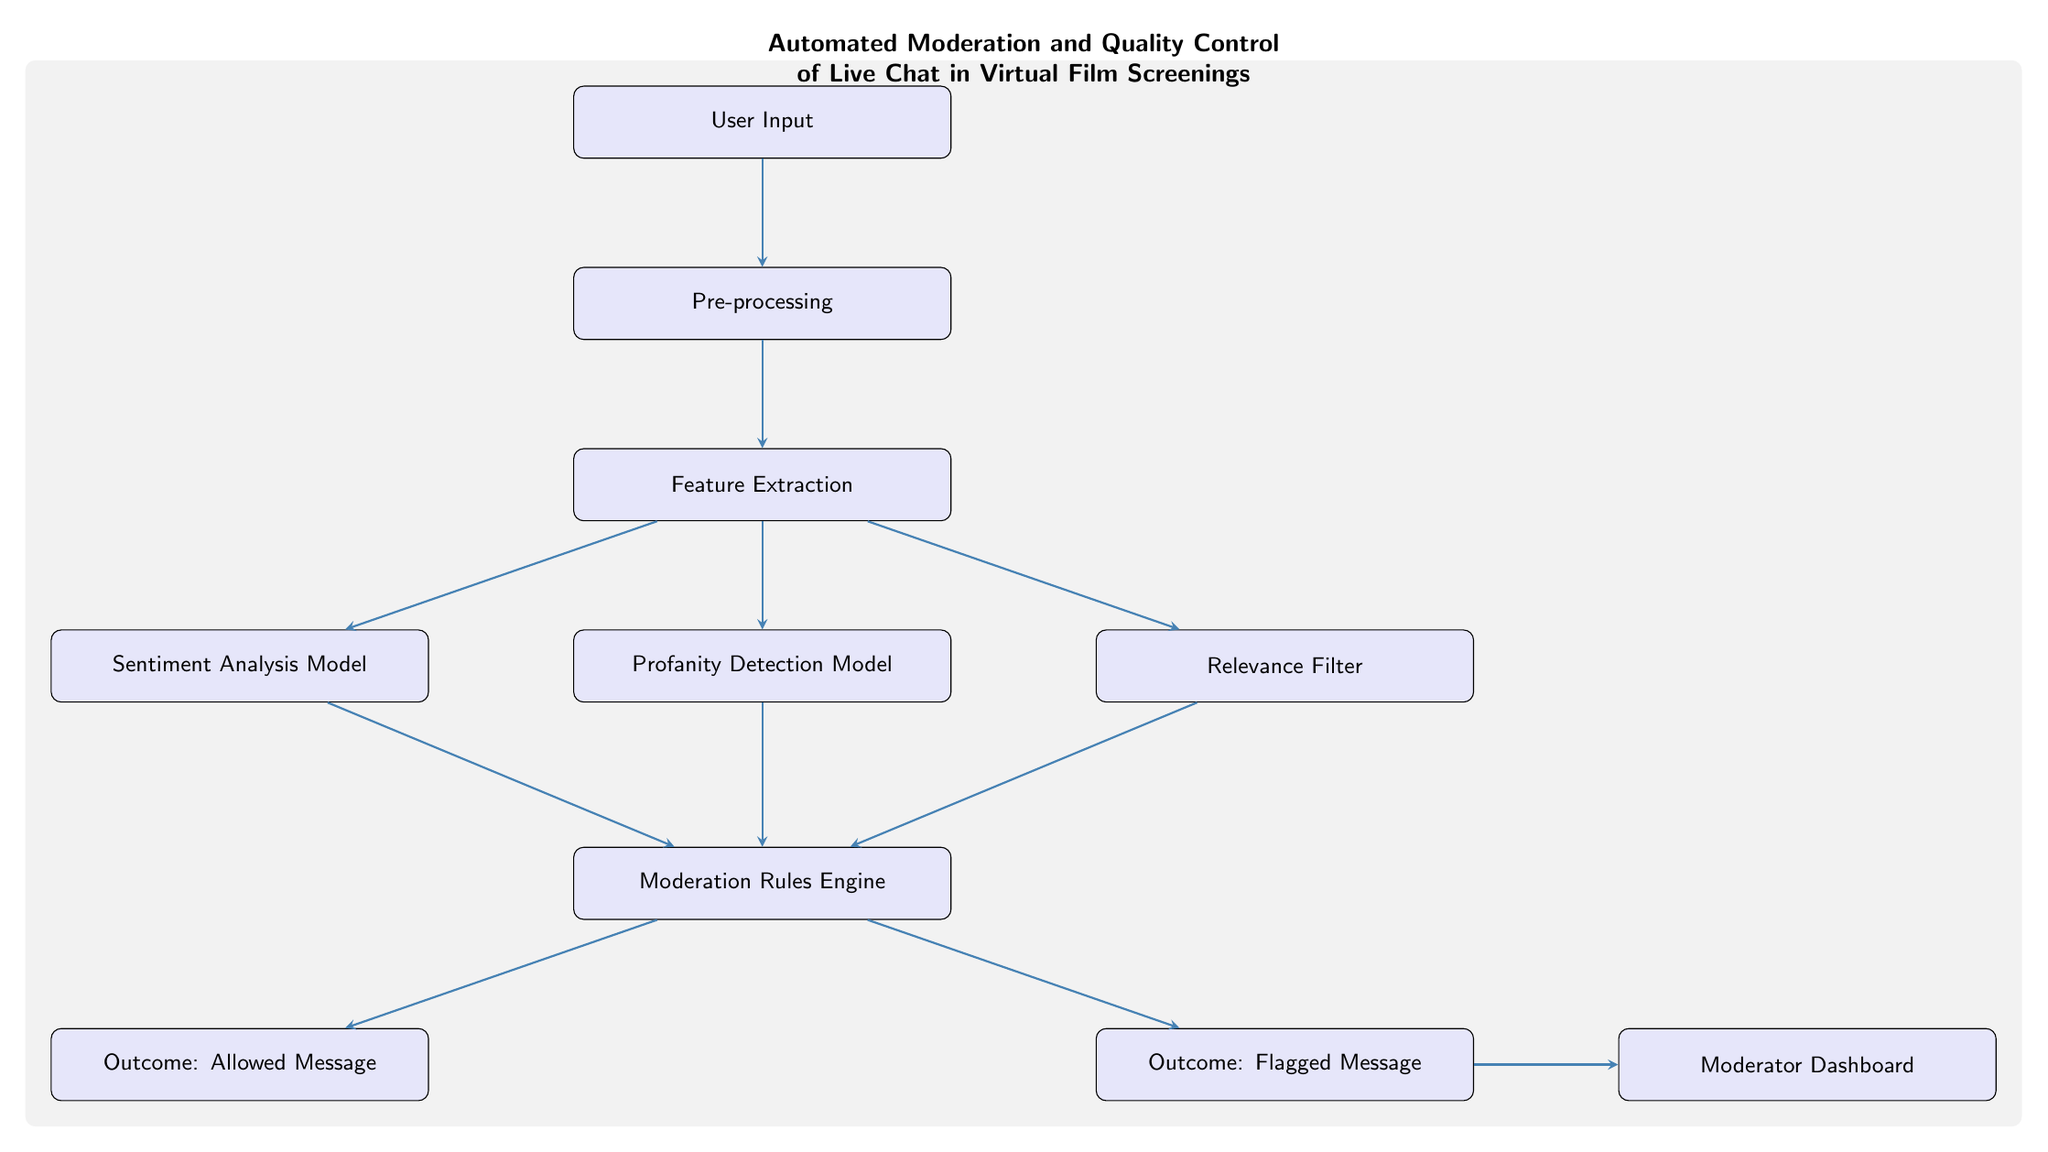What is the first process in the diagram? The first process is labeled as "User Input," which is the starting point in the flow of the diagram.
Answer: User Input How many models are present in the diagram? There are three models shown: Sentiment Analysis Model, Profanity Detection Model, and Relevance Filter.
Answer: Three What is the outcome of the rules engine when a message is not allowed? The rules engine processes messages, and if a message is not allowed, it results in a "Flagged Message."
Answer: Flagged Message Which process directly feeds into the Moderator Dashboard? The "Flagged Message" outcome from the rules engine connects directly to the Moderator Dashboard for review and action.
Answer: Flagged Message What are the three types of analysis performed after feature extraction? The analysis types performed are Sentiment Analysis, Profanity Detection, and Relevance Filtering.
Answer: Sentiment Analysis, Profanity Detection, Relevance Filtering What is the last node in the flow of the diagram? The last node represents the "Moderator Dashboard," where flagged messages can be monitored and responded to.
Answer: Moderator Dashboard What connects the "Proficiency Detection Model" to the "Rules Engine"? There is a direct arrow indicating that the results from the Profanity Detection Model feed into the Moderation Rules Engine.
Answer: Arrow How many outcomes are shown from the Rules Engine? The diagram shows two outcomes from the Rules Engine: Allowed Message and Flagged Message.
Answer: Two What does the "Feature Extraction" node output to? The Feature Extraction node outputs to three models: Sentiment Analysis Model, Profanity Detection Model, and Relevance Filter.
Answer: Three models 